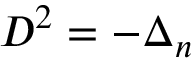<formula> <loc_0><loc_0><loc_500><loc_500>D ^ { 2 } = - \Delta _ { n }</formula> 